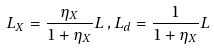Convert formula to latex. <formula><loc_0><loc_0><loc_500><loc_500>L _ { X } = \frac { \eta _ { X } } { 1 + \eta _ { X } } L \, , L _ { d } = \frac { 1 } { 1 + \eta _ { X } } L</formula> 